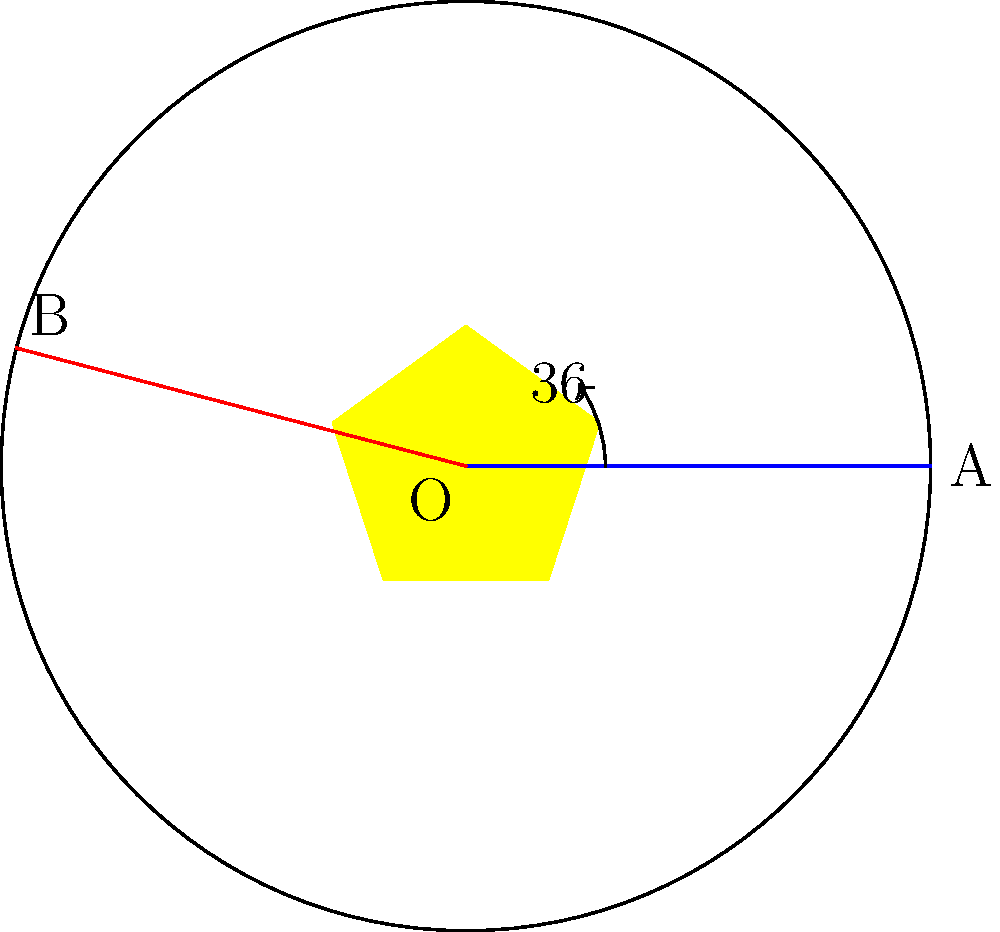In the Għarb Rangers F.C. crest, a regular star is centered within a circular border. If OA is the horizontal radius and OB is another radius forming a $72°$ angle with OA, what is the measure of angle AOB if OC is the angle bisector of AOB? Let's approach this step-by-step:

1) First, we need to understand what an angle bisector is. An angle bisector divides an angle into two equal parts.

2) We're given that OA and OB form a $72°$ angle. Let's call this angle $\theta$.

3) If OC is the angle bisector of AOB, it means that:
   $$\angle AOC = \angle BOC = \frac{\theta}{2}$$

4) We know that $\theta = 72°$

5) Therefore:
   $$\angle AOC = \angle BOC = \frac{72°}{2} = 36°$$

6) The question asks for the measure of angle AOB, which we've been calling $\theta$. We already know this is $72°$.

This question relates to the Għarb Rangers F.C. crest by using its circular shape and the star within it as a reference for the angle measurements.
Answer: $72°$ 